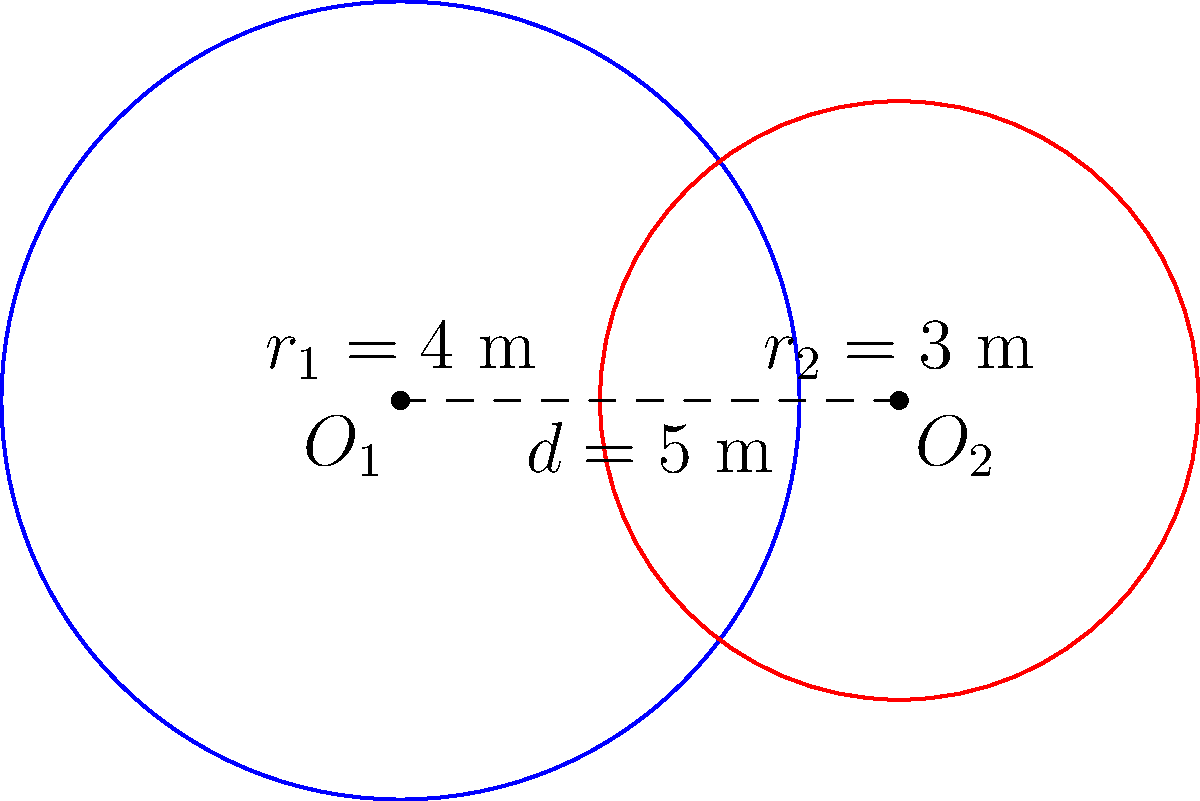At the Taiheiyo Club Gotemba Course, two circular putting practice areas overlap as shown. The larger area has a radius of 4 meters, while the smaller one has a radius of 3 meters. The centers of the circles are 5 meters apart. Calculate the area of the overlapping region to determine the shared practice space available for players like Hinako Shibuno. To find the area of overlap between two circles, we'll use the formula for the area of intersection:

$$A = r_1^2 \arccos(\frac{d^2 + r_1^2 - r_2^2}{2dr_1}) + r_2^2 \arccos(\frac{d^2 + r_2^2 - r_1^2}{2dr_2}) - \frac{1}{2}\sqrt{(-d+r_1+r_2)(d+r_1-r_2)(d-r_1+r_2)(d+r_1+r_2)}$$

Where:
$r_1 = 4$ m (radius of larger circle)
$r_2 = 3$ m (radius of smaller circle)
$d = 5$ m (distance between centers)

Step 1: Calculate the first term
$$r_1^2 \arccos(\frac{d^2 + r_1^2 - r_2^2}{2dr_1}) = 16 \arccos(\frac{25 + 16 - 9}{2 \cdot 5 \cdot 4}) \approx 8.2982$$

Step 2: Calculate the second term
$$r_2^2 \arccos(\frac{d^2 + r_2^2 - r_1^2}{2dr_2}) = 9 \arccos(\frac{25 + 9 - 16}{2 \cdot 5 \cdot 3}) \approx 2.6981$$

Step 3: Calculate the third term
$$\frac{1}{2}\sqrt{(-d+r_1+r_2)(d+r_1-r_2)(d-r_1+r_2)(d+r_1+r_2)} = \frac{1}{2}\sqrt{(2)(2)(4)(12)} = \sqrt{48} \approx 6.9282$$

Step 4: Sum up the terms
$$A = 8.2982 + 2.6981 - 6.9282 \approx 4.0681$$

Therefore, the area of the overlapping region is approximately 4.0681 square meters.
Answer: $4.07$ m² 